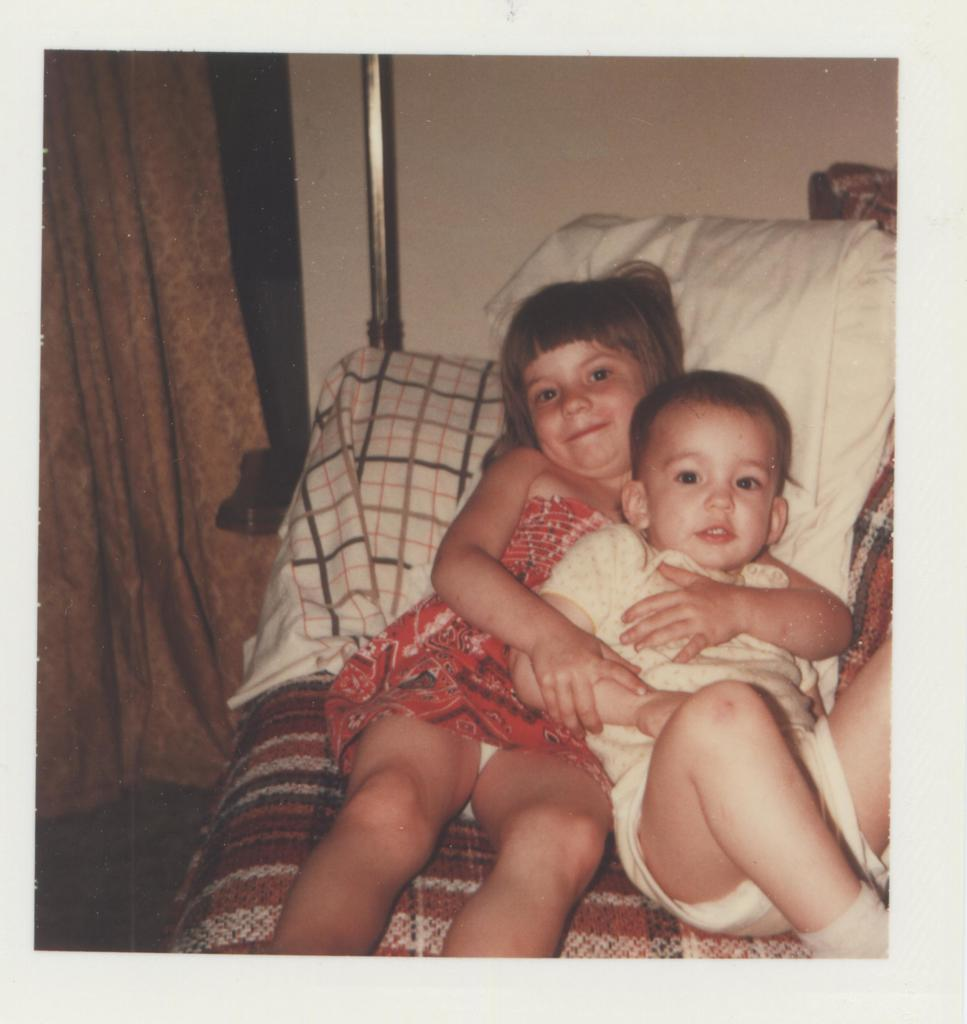Who is present in the image? There is a boy and a girl in the image. What are the boy and girl doing in the image? The boy and girl are holding each other. Where are they located in the image? They are lying on a bed. What can be seen in the background of the image? There is a wall visible in the image. Are there any objects or structures in the image? Yes, there is a pole and a curtain in the image. What type of volleyball is being played in the image? There is no volleyball being played in the image. 